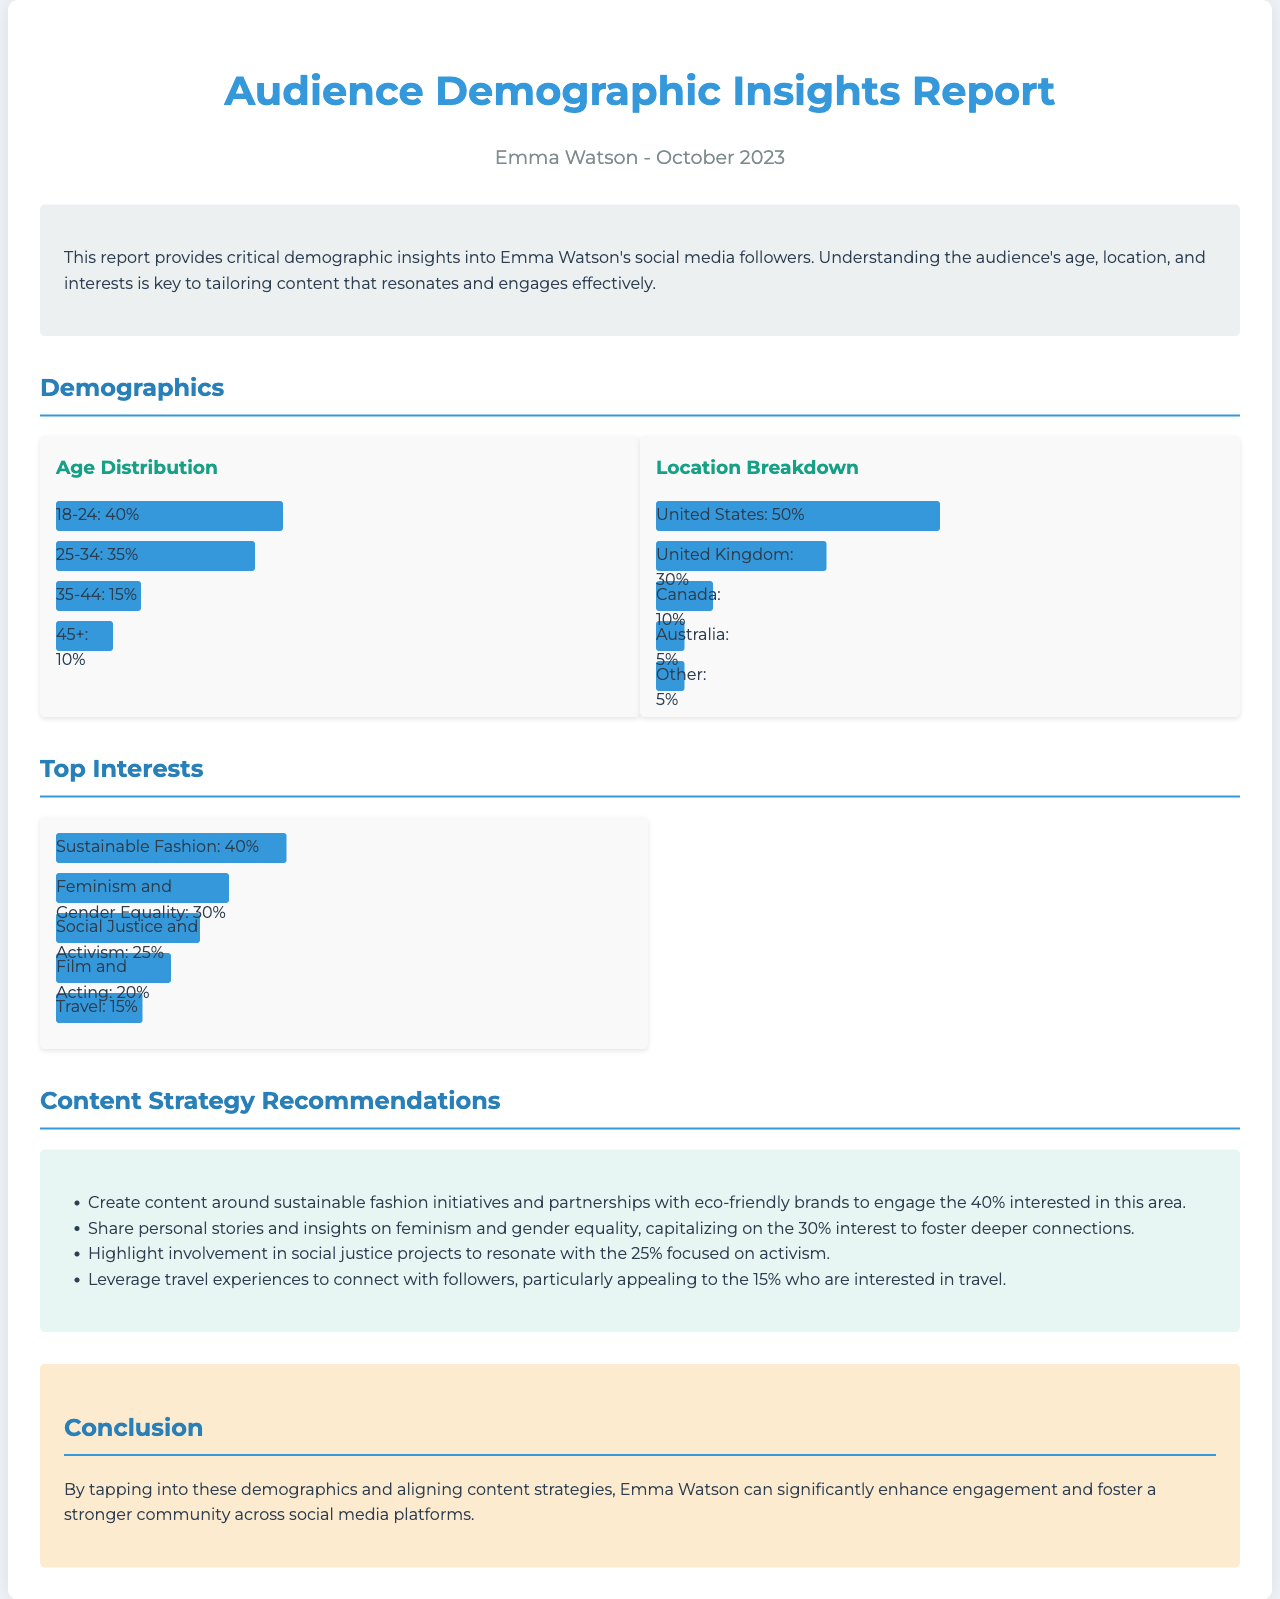what is the age group with the highest percentage? The document states that the age group 18-24 has the highest percentage at 40%.
Answer: 18-24 what percentage of followers are located in the United States? According to the location breakdown, 50% of followers are from the United States.
Answer: 50% which interest has the lowest percentage among the top interests? The lowest percentage among the top interests listed is travel at 15%.
Answer: Travel what is the recommended content focus for the 30% interested in feminism? The report suggests sharing personal stories and insights on feminism and gender equality for the 30% interested.
Answer: Personal stories how many total age categories are presented in the age distribution? The age distribution section presents four categories: 18-24, 25-34, 35-44, and 45+.
Answer: Four what percentage of followers are interested in sustainable fashion? The report indicates that 40% of followers are interested in sustainable fashion.
Answer: 40% which location has the second highest percentage of followers? The second highest percentage of followers is from the United Kingdom at 30%.
Answer: United Kingdom how many content strategy recommendations are provided in the report? The report provides four content strategy recommendations.
Answer: Four 